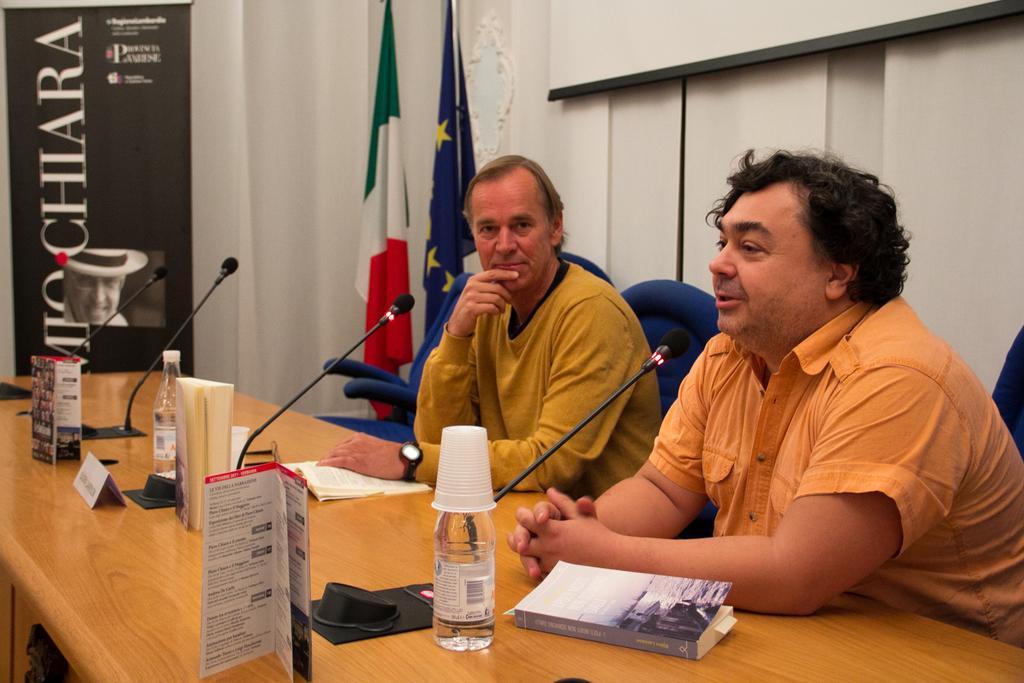Could you give a brief overview of what you see in this image? In the image there are two men sat on chair in front of table,one is talking on mic and in front there is a book and a bottle with cups and on the wall there are two flags. 